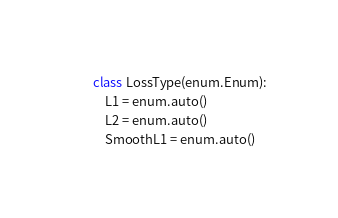Convert code to text. <code><loc_0><loc_0><loc_500><loc_500><_Python_>class LossType(enum.Enum):
    L1 = enum.auto()
    L2 = enum.auto()
    SmoothL1 = enum.auto()
</code> 